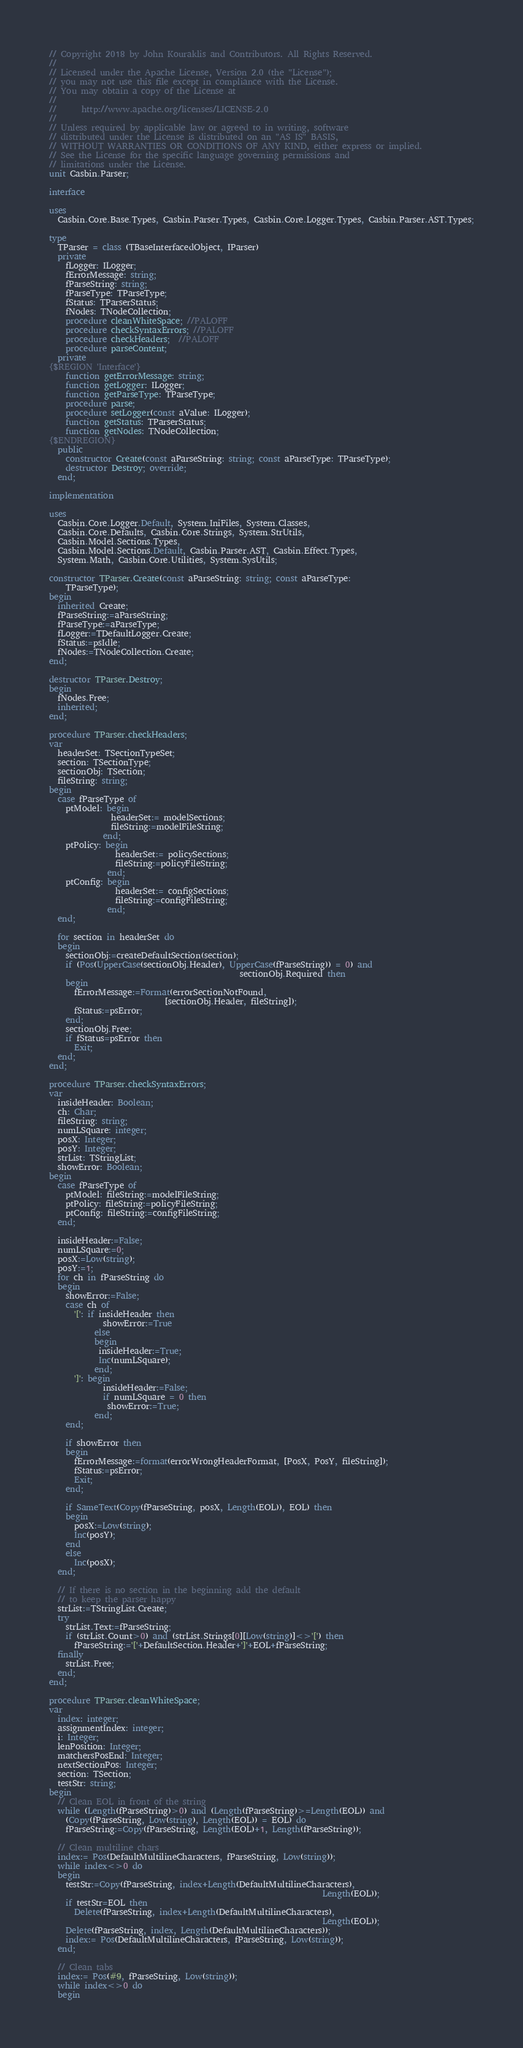<code> <loc_0><loc_0><loc_500><loc_500><_Pascal_>// Copyright 2018 by John Kouraklis and Contributors. All Rights Reserved.
//
// Licensed under the Apache License, Version 2.0 (the "License");
// you may not use this file except in compliance with the License.
// You may obtain a copy of the License at
//
//      http://www.apache.org/licenses/LICENSE-2.0
//
// Unless required by applicable law or agreed to in writing, software
// distributed under the License is distributed on an "AS IS" BASIS,
// WITHOUT WARRANTIES OR CONDITIONS OF ANY KIND, either express or implied.
// See the License for the specific language governing permissions and
// limitations under the License.
unit Casbin.Parser;

interface

uses
  Casbin.Core.Base.Types, Casbin.Parser.Types, Casbin.Core.Logger.Types, Casbin.Parser.AST.Types;

type
  TParser = class (TBaseInterfacedObject, IParser)
  private
    fLogger: ILogger;
    fErrorMessage: string;
    fParseString: string;
    fParseType: TParseType;
    fStatus: TParserStatus;
    fNodes: TNodeCollection;
    procedure cleanWhiteSpace; //PALOFF
    procedure checkSyntaxErrors; //PALOFF
    procedure checkHeaders;  //PALOFF
    procedure parseContent;
  private
{$REGION 'Interface'}
    function getErrorMessage: string;
    function getLogger: ILogger;
    function getParseType: TParseType;
    procedure parse;
    procedure setLogger(const aValue: ILogger);
    function getStatus: TParserStatus;
    function getNodes: TNodeCollection;
{$ENDREGION}
  public
    constructor Create(const aParseString: string; const aParseType: TParseType);
    destructor Destroy; override;
  end;

implementation

uses
  Casbin.Core.Logger.Default, System.IniFiles, System.Classes,
  Casbin.Core.Defaults, Casbin.Core.Strings, System.StrUtils,
  Casbin.Model.Sections.Types,
  Casbin.Model.Sections.Default, Casbin.Parser.AST, Casbin.Effect.Types,
  System.Math, Casbin.Core.Utilities, System.SysUtils;

constructor TParser.Create(const aParseString: string; const aParseType:
    TParseType);
begin
  inherited Create;
  fParseString:=aParseString;
  fParseType:=aParseType;
  fLogger:=TDefaultLogger.Create;
  fStatus:=psIdle;
  fNodes:=TNodeCollection.Create;
end;

destructor TParser.Destroy;
begin
  fNodes.Free;
  inherited;
end;

procedure TParser.checkHeaders;
var
  headerSet: TSectionTypeSet;
  section: TSectionType;
  sectionObj: TSection;
  fileString: string;
begin
  case fParseType of
    ptModel: begin
               headerSet:= modelSections;
               fileString:=modelFileString;
             end;
    ptPolicy: begin
                headerSet:= policySections;
                fileString:=policyFileString;
              end;
    ptConfig: begin
                headerSet:= configSections;
                fileString:=configFileString;
              end;
  end;

  for section in headerSet do
  begin
    sectionObj:=createDefaultSection(section);
    if (Pos(UpperCase(sectionObj.Header), UpperCase(fParseString)) = 0) and
                                              sectionObj.Required then
    begin
      fErrorMessage:=Format(errorSectionNotFound,
                            [sectionObj.Header, fileString]);
      fStatus:=psError;
    end;
    sectionObj.Free;
    if fStatus=psError then
      Exit;
  end;
end;

procedure TParser.checkSyntaxErrors;
var
  insideHeader: Boolean;
  ch: Char;
  fileString: string;
  numLSquare: integer;
  posX: Integer;
  posY: Integer;
  strList: TStringList;
  showError: Boolean;
begin
  case fParseType of
    ptModel: fileString:=modelFileString;
    ptPolicy: fileString:=policyFileString;
    ptConfig: fileString:=configFileString;
  end;

  insideHeader:=False;
  numLSquare:=0;
  posX:=Low(string);
  posY:=1;
  for ch in fParseString do
  begin
    showError:=False;
    case ch of
      '[': if insideHeader then
             showError:=True
           else
           begin
            insideHeader:=True;
            Inc(numLSquare);
           end;
      ']': begin
             insideHeader:=False;
             if numLSquare = 0 then
              showError:=True;
           end;
    end;

    if showError then
    begin
      fErrorMessage:=format(errorWrongHeaderFormat, [PosX, PosY, fileString]);
      fStatus:=psError;
      Exit;
    end;

    if SameText(Copy(fParseString, posX, Length(EOL)), EOL) then
    begin
      posX:=Low(string);
      Inc(posY);
    end
    else
      Inc(posX);
  end;

  // If there is no section in the beginning add the default
  // to keep the parser happy
  strList:=TStringList.Create;
  try
    strList.Text:=fParseString;
    if (strList.Count>0) and (strList.Strings[0][Low(string)]<>'[') then
      fParseString:='['+DefaultSection.Header+']'+EOL+fParseString;
  finally
    strList.Free;
  end;
end;

procedure TParser.cleanWhiteSpace;
var
  index: integer;
  assignmentIndex: integer;
  i: Integer;
  lenPosition: Integer;
  matchersPosEnd: Integer;
  nextSectionPos: Integer;
  section: TSection;
  testStr: string;
begin
  // Clean EOL in front of the string
  while (Length(fParseString)>0) and (Length(fParseString)>=Length(EOL)) and
    (Copy(fParseString, Low(string), Length(EOL)) = EOL) do
    fParseString:=Copy(fParseString, Length(EOL)+1, Length(fParseString));

  // Clean multiline chars
  index:= Pos(DefaultMultilineCharacters, fParseString, Low(string));
  while index<>0 do
  begin
    testStr:=Copy(fParseString, index+Length(DefaultMultilineCharacters),
                                                                  Length(EOL));
    if testStr=EOL then
      Delete(fParseString, index+Length(DefaultMultilineCharacters),
                                                                  Length(EOL));
    Delete(fParseString, index, Length(DefaultMultilineCharacters));
    index:= Pos(DefaultMultilineCharacters, fParseString, Low(string));
  end;

  // Clean tabs
  index:= Pos(#9, fParseString, Low(string));
  while index<>0 do
  begin</code> 